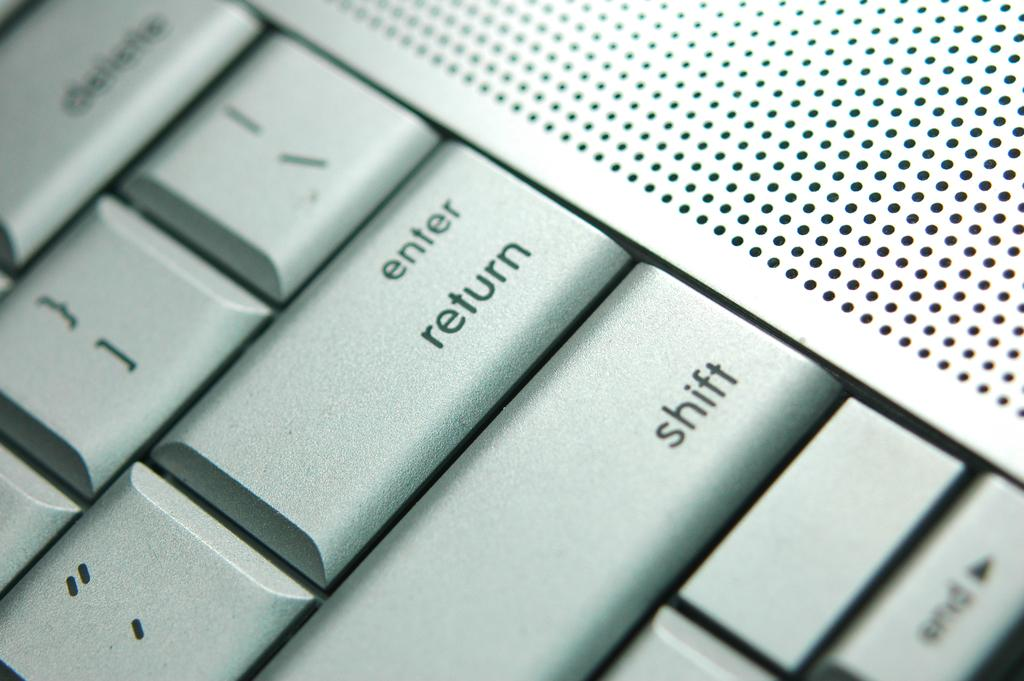<image>
Offer a succinct explanation of the picture presented. The keyboard has its Enter key right above the Shift key. 